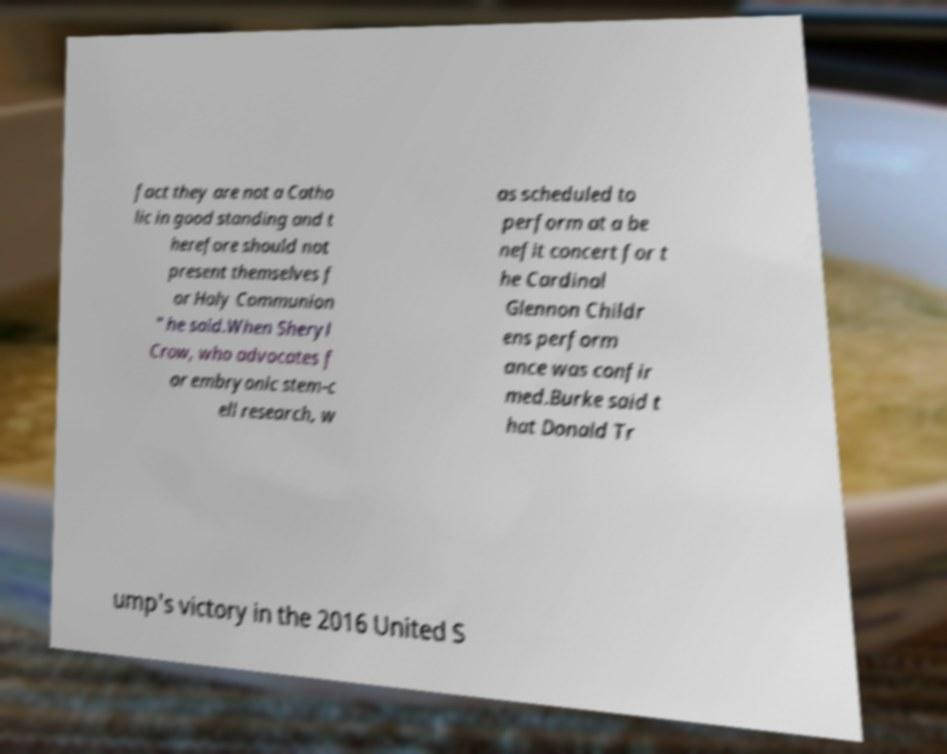Could you assist in decoding the text presented in this image and type it out clearly? fact they are not a Catho lic in good standing and t herefore should not present themselves f or Holy Communion " he said.When Sheryl Crow, who advocates f or embryonic stem-c ell research, w as scheduled to perform at a be nefit concert for t he Cardinal Glennon Childr ens perform ance was confir med.Burke said t hat Donald Tr ump's victory in the 2016 United S 